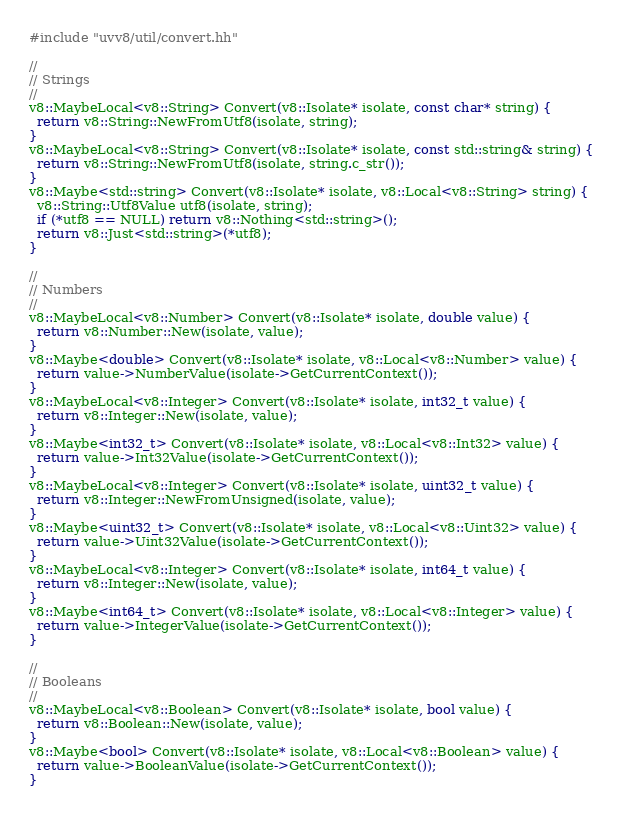Convert code to text. <code><loc_0><loc_0><loc_500><loc_500><_C++_>#include "uvv8/util/convert.hh"

//
// Strings
//
v8::MaybeLocal<v8::String> Convert(v8::Isolate* isolate, const char* string) {
  return v8::String::NewFromUtf8(isolate, string);
}
v8::MaybeLocal<v8::String> Convert(v8::Isolate* isolate, const std::string& string) {
  return v8::String::NewFromUtf8(isolate, string.c_str());
}
v8::Maybe<std::string> Convert(v8::Isolate* isolate, v8::Local<v8::String> string) {
  v8::String::Utf8Value utf8(isolate, string);
  if (*utf8 == NULL) return v8::Nothing<std::string>();
  return v8::Just<std::string>(*utf8);
}

//
// Numbers
//
v8::MaybeLocal<v8::Number> Convert(v8::Isolate* isolate, double value) {
  return v8::Number::New(isolate, value);
}
v8::Maybe<double> Convert(v8::Isolate* isolate, v8::Local<v8::Number> value) {
  return value->NumberValue(isolate->GetCurrentContext());
}
v8::MaybeLocal<v8::Integer> Convert(v8::Isolate* isolate, int32_t value) {
  return v8::Integer::New(isolate, value);
}
v8::Maybe<int32_t> Convert(v8::Isolate* isolate, v8::Local<v8::Int32> value) {
  return value->Int32Value(isolate->GetCurrentContext());
}
v8::MaybeLocal<v8::Integer> Convert(v8::Isolate* isolate, uint32_t value) {
  return v8::Integer::NewFromUnsigned(isolate, value);
}
v8::Maybe<uint32_t> Convert(v8::Isolate* isolate, v8::Local<v8::Uint32> value) {
  return value->Uint32Value(isolate->GetCurrentContext());
}
v8::MaybeLocal<v8::Integer> Convert(v8::Isolate* isolate, int64_t value) {
  return v8::Integer::New(isolate, value);
}
v8::Maybe<int64_t> Convert(v8::Isolate* isolate, v8::Local<v8::Integer> value) {
  return value->IntegerValue(isolate->GetCurrentContext());
}

//
// Booleans
//
v8::MaybeLocal<v8::Boolean> Convert(v8::Isolate* isolate, bool value) {
  return v8::Boolean::New(isolate, value);
}
v8::Maybe<bool> Convert(v8::Isolate* isolate, v8::Local<v8::Boolean> value) {
  return value->BooleanValue(isolate->GetCurrentContext());
}
</code> 